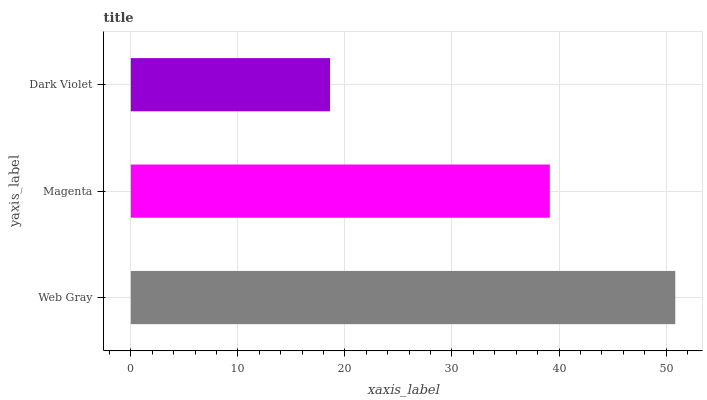Is Dark Violet the minimum?
Answer yes or no. Yes. Is Web Gray the maximum?
Answer yes or no. Yes. Is Magenta the minimum?
Answer yes or no. No. Is Magenta the maximum?
Answer yes or no. No. Is Web Gray greater than Magenta?
Answer yes or no. Yes. Is Magenta less than Web Gray?
Answer yes or no. Yes. Is Magenta greater than Web Gray?
Answer yes or no. No. Is Web Gray less than Magenta?
Answer yes or no. No. Is Magenta the high median?
Answer yes or no. Yes. Is Magenta the low median?
Answer yes or no. Yes. Is Web Gray the high median?
Answer yes or no. No. Is Dark Violet the low median?
Answer yes or no. No. 